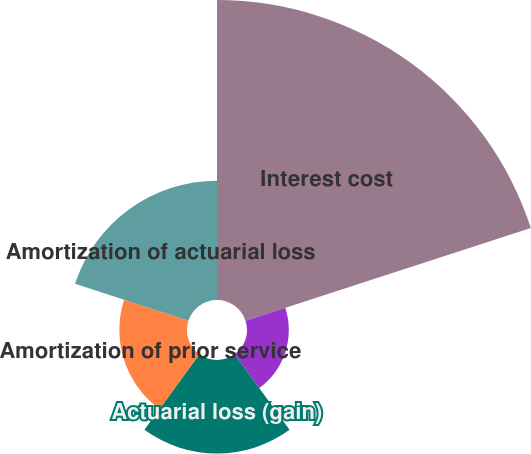Convert chart. <chart><loc_0><loc_0><loc_500><loc_500><pie_chart><fcel>Interest cost<fcel>Prior service cost (credit)<fcel>Actuarial loss (gain)<fcel>Amortization of prior service<fcel>Amortization of actuarial loss<nl><fcel>48.22%<fcel>6.72%<fcel>15.02%<fcel>10.87%<fcel>19.17%<nl></chart> 